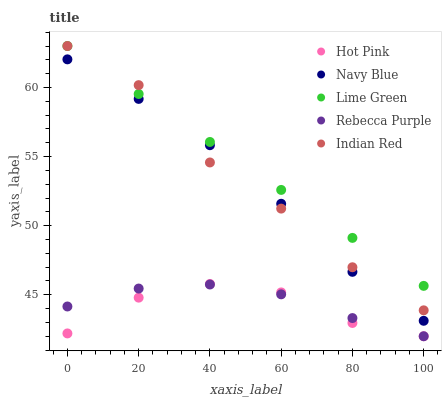Does Hot Pink have the minimum area under the curve?
Answer yes or no. Yes. Does Lime Green have the maximum area under the curve?
Answer yes or no. Yes. Does Lime Green have the minimum area under the curve?
Answer yes or no. No. Does Hot Pink have the maximum area under the curve?
Answer yes or no. No. Is Lime Green the smoothest?
Answer yes or no. Yes. Is Indian Red the roughest?
Answer yes or no. Yes. Is Hot Pink the smoothest?
Answer yes or no. No. Is Hot Pink the roughest?
Answer yes or no. No. Does Hot Pink have the lowest value?
Answer yes or no. Yes. Does Lime Green have the lowest value?
Answer yes or no. No. Does Indian Red have the highest value?
Answer yes or no. Yes. Does Hot Pink have the highest value?
Answer yes or no. No. Is Hot Pink less than Lime Green?
Answer yes or no. Yes. Is Navy Blue greater than Hot Pink?
Answer yes or no. Yes. Does Indian Red intersect Lime Green?
Answer yes or no. Yes. Is Indian Red less than Lime Green?
Answer yes or no. No. Is Indian Red greater than Lime Green?
Answer yes or no. No. Does Hot Pink intersect Lime Green?
Answer yes or no. No. 